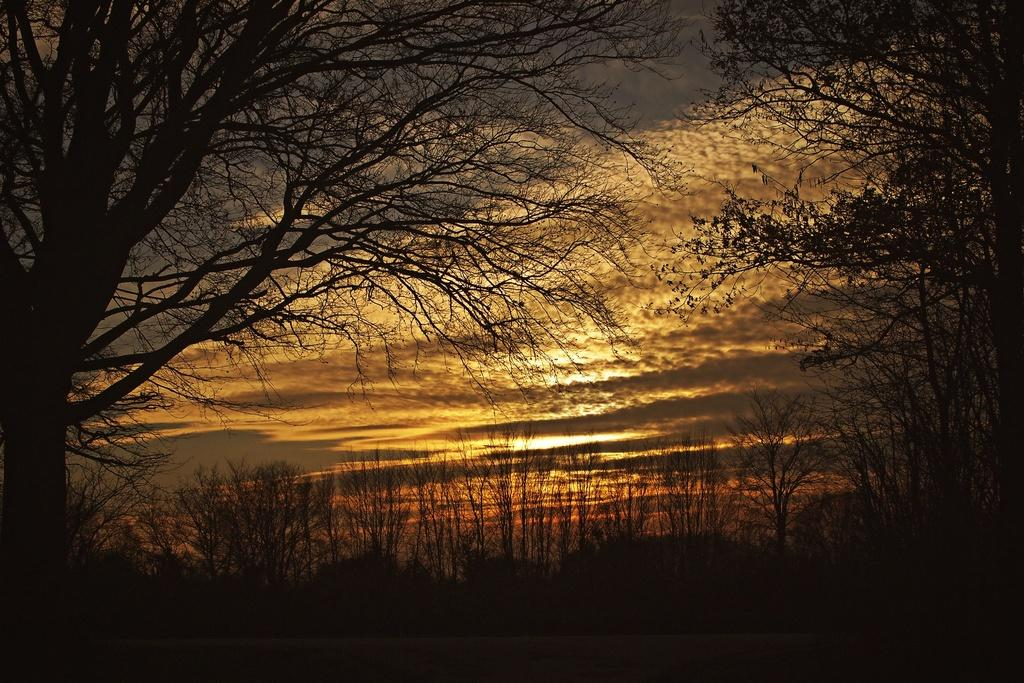What type of vegetation can be seen in the image? There are trees in the image. What is the condition of the sky in the image? The sky is cloudy in the image. Can you describe the lighting in the image? Sunlight is visible in the image. How many chairs are placed under the trees in the image? There are no chairs present in the image; it only features trees and a cloudy sky. What type of wool can be seen in the image? There is no wool present in the image. 